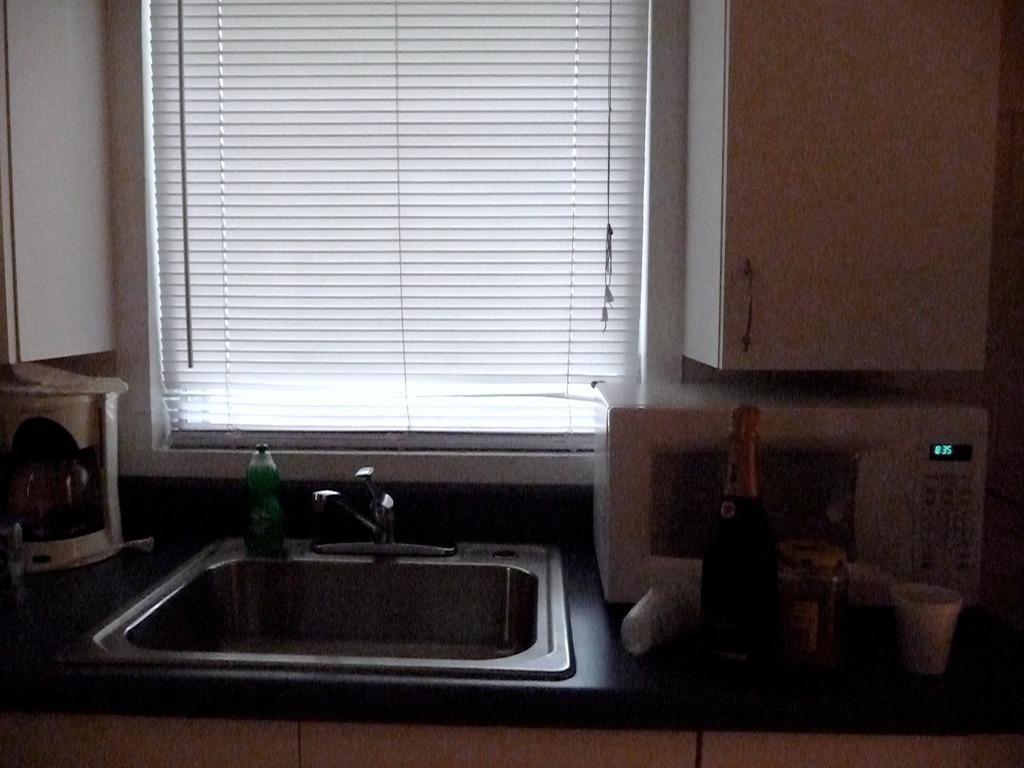Describe this image in one or two sentences. This picture is taken inside the kitchen. In this image, we can see a table, on the right side of the table, we can see a microwave oven, bottle and a glass. On the left side of the table, we can also see a electronic instrument. In the middle of the table, we can also see a musical instrument. In the background, we can see water tap, bottle, window and a wall. 